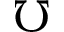Convert formula to latex. <formula><loc_0><loc_0><loc_500><loc_500>\mho</formula> 